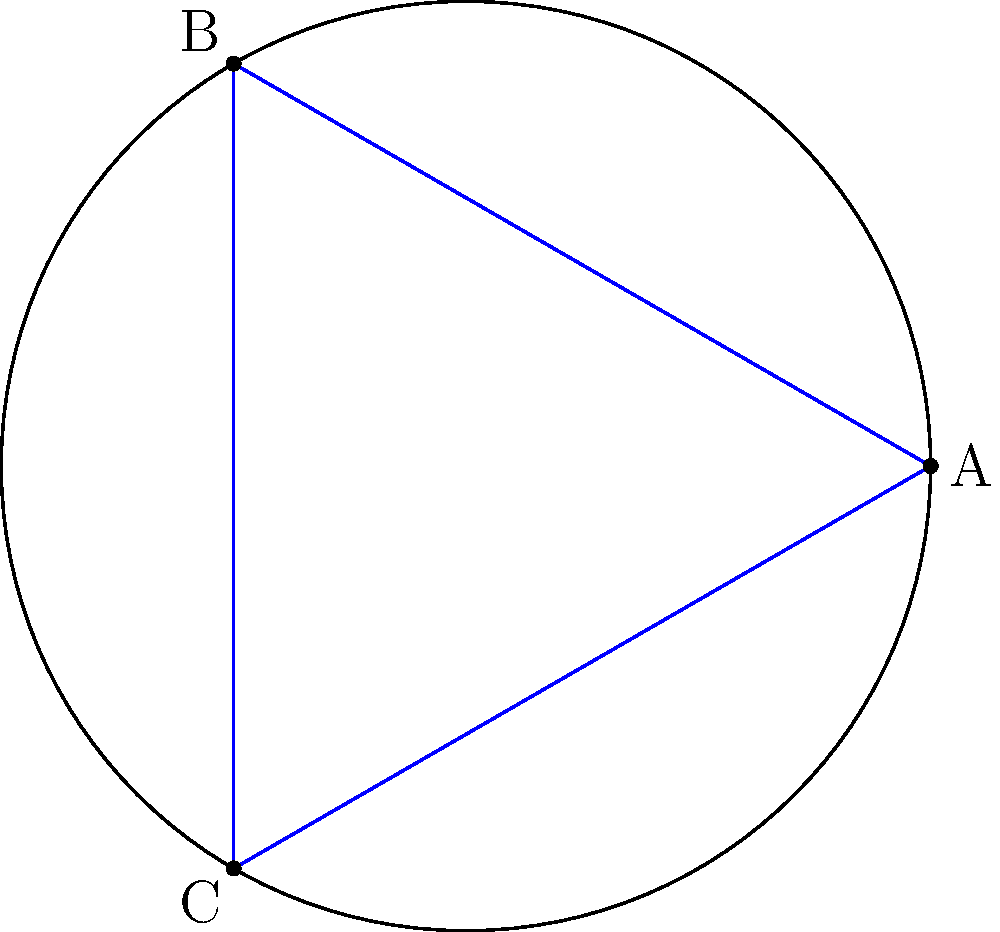In the context of non-Euclidean symmetry in music notation, consider the equilateral triangle ABC inscribed in a unit circle as shown. If this representation is mapped onto a hyperbolic plane, how would the sum of the internal angles of the triangle change, and how might this relate to musical intervals? To understand this concept, let's break it down step-by-step:

1. In Euclidean geometry, the sum of the internal angles of any triangle is always 180°.

2. However, in hyperbolic geometry (a type of non-Euclidean geometry), the sum of the internal angles of a triangle is always less than 180°.

3. The difference between 180° and the actual sum of the angles is called the defect of the triangle.

4. In hyperbolic geometry, as the area of the triangle increases, the sum of its angles decreases.

5. Relating this to music:
   - In Western music, the octave is divided into 12 equal parts (semitones).
   - This division is based on Euclidean geometry and results in equal temperament tuning.

6. In hyperbolic geometry, we could imagine a musical system where:
   - The "defect" of the triangle represents a deviation from standard tuning.
   - Larger triangles (with smaller angle sums) could represent lower frequencies.
   - Smaller triangles (with larger angle sums) could represent higher frequencies.

7. This could lead to a non-linear tuning system, where the intervals between notes are not constant across the frequency spectrum, potentially creating new harmonic relationships and timbres.

8. Such a system could be used to create microtonal music or to explore alternative tuning systems that might have therapeutic applications due to their unique harmonic structures.
Answer: The sum of internal angles would be less than 180°, potentially representing a non-linear tuning system with varying intervals. 